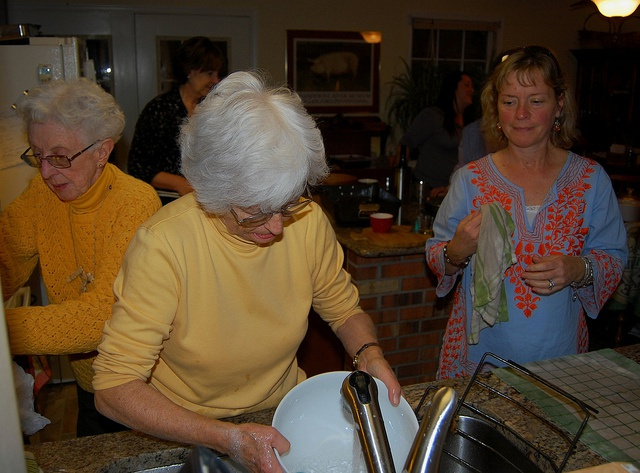Describe the objects in this image and their specific colors. I can see people in black, tan, olive, gray, and darkgray tones, people in black, gray, maroon, and blue tones, people in black, brown, maroon, and gray tones, bowl in black, darkgray, and gray tones, and people in black, maroon, and gray tones in this image. 